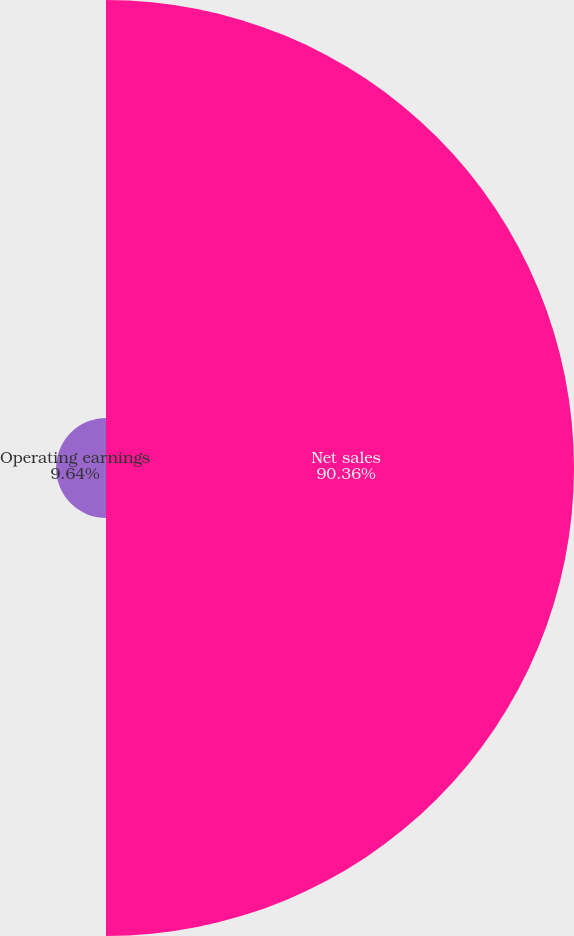<chart> <loc_0><loc_0><loc_500><loc_500><pie_chart><fcel>Net sales<fcel>Operating earnings<nl><fcel>90.36%<fcel>9.64%<nl></chart> 